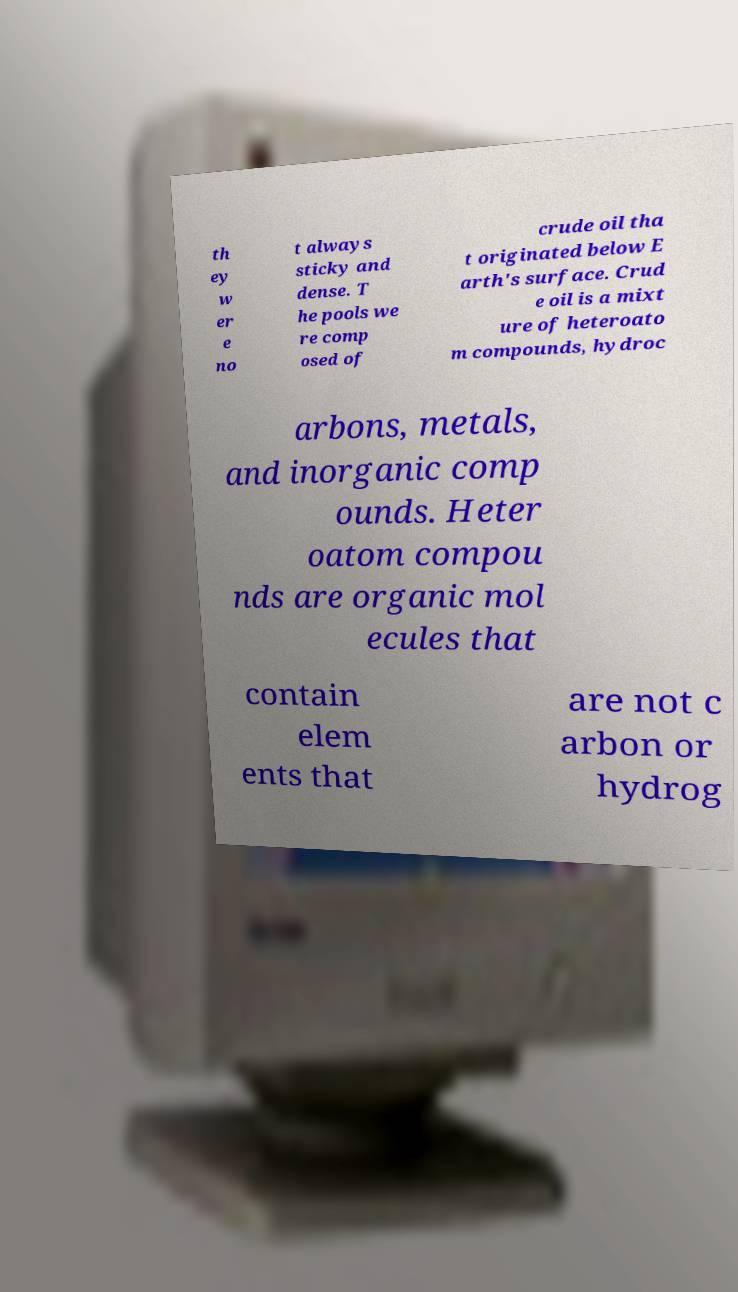Can you accurately transcribe the text from the provided image for me? th ey w er e no t always sticky and dense. T he pools we re comp osed of crude oil tha t originated below E arth's surface. Crud e oil is a mixt ure of heteroato m compounds, hydroc arbons, metals, and inorganic comp ounds. Heter oatom compou nds are organic mol ecules that contain elem ents that are not c arbon or hydrog 